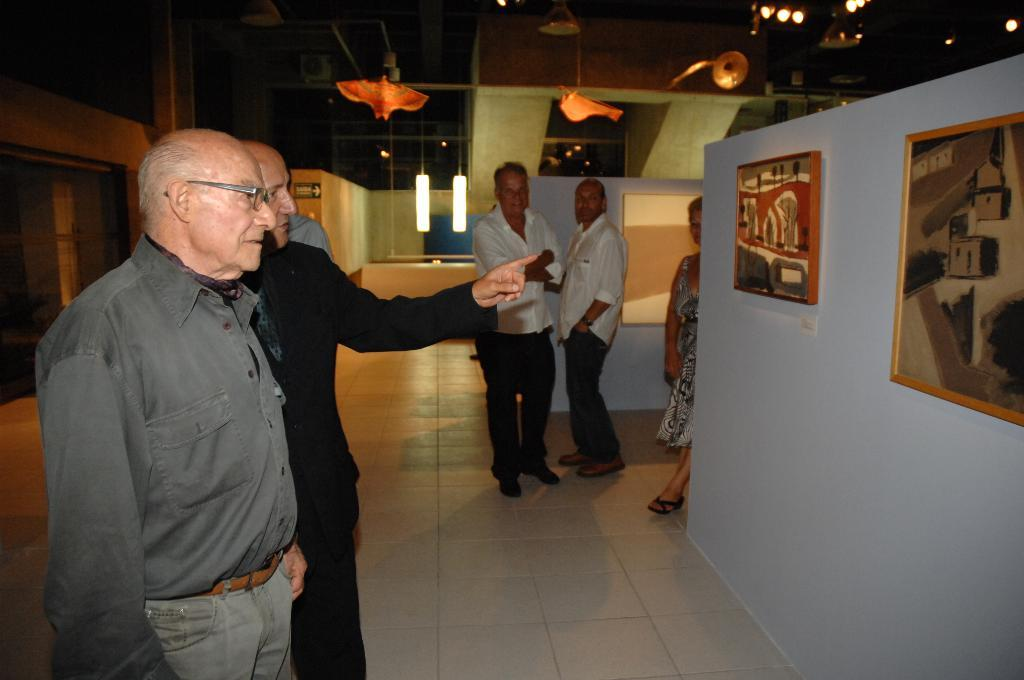What are the people in the image doing? The people in the image are watching art. Where is the scene taking place? The setting is inside an art gallery. What can be seen in the background of the image? There are lamps in the background of the image. What is the price of the birthday cake that the aunt brought to the art gallery? There is no mention of a birthday cake or an aunt in the image, so we cannot determine the price of a birthday cake. 